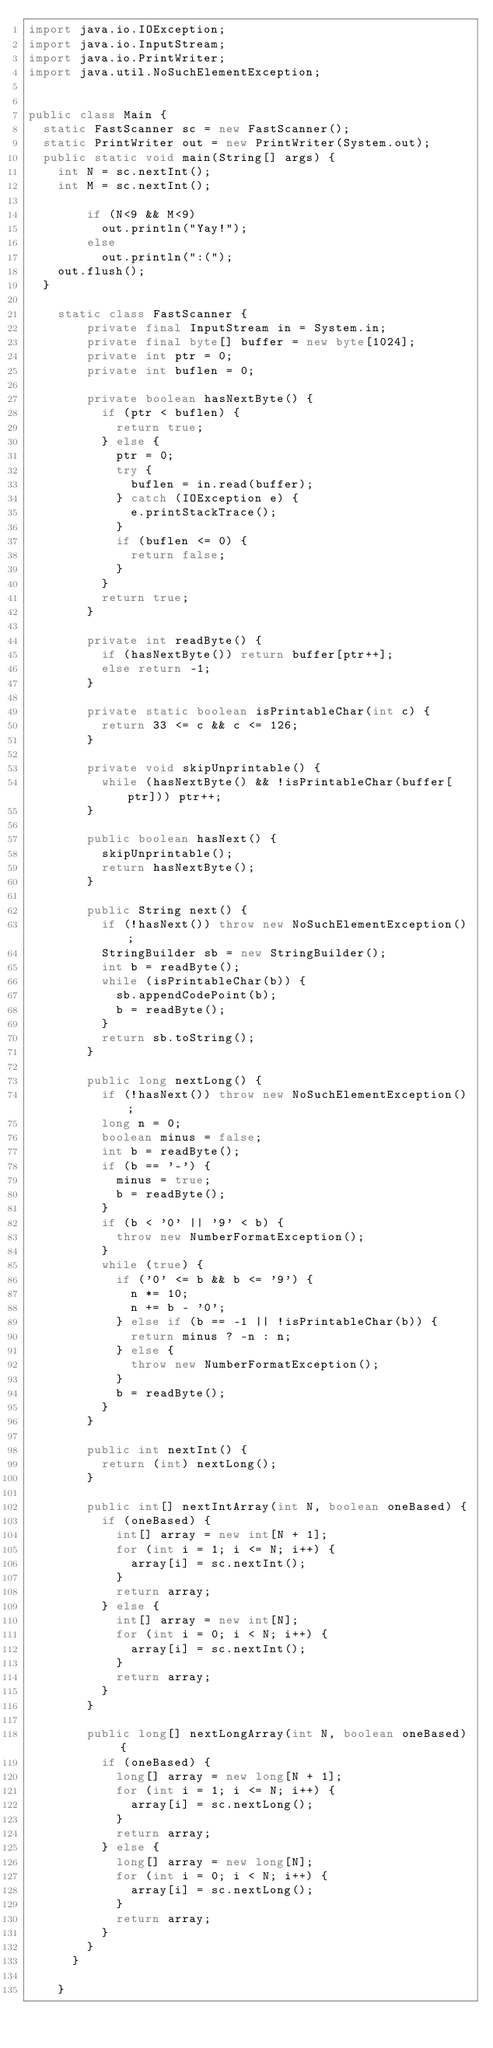<code> <loc_0><loc_0><loc_500><loc_500><_Java_>import java.io.IOException;
import java.io.InputStream;
import java.io.PrintWriter;
import java.util.NoSuchElementException;


public class Main {
	static FastScanner sc = new FastScanner();
	static PrintWriter out = new PrintWriter(System.out);
	public static void main(String[] args) {
		int N = sc.nextInt();
		int M = sc.nextInt();
	
        if (N<9 && M<9)
        	out.println("Yay!");
        else
        	out.println(":(");
		out.flush();
	}
	
		static class FastScanner {
		    private final InputStream in = System.in;
		    private final byte[] buffer = new byte[1024];
		    private int ptr = 0;
		    private int buflen = 0;

		    private boolean hasNextByte() {
		      if (ptr < buflen) {
		        return true;
		      } else {
		        ptr = 0;
		        try {
		          buflen = in.read(buffer);
		        } catch (IOException e) {
		          e.printStackTrace();
		        }
		        if (buflen <= 0) {
		          return false;
		        }
		      }
		      return true;
		    }

		    private int readByte() {
		      if (hasNextByte()) return buffer[ptr++];
		      else return -1;
		    }

		    private static boolean isPrintableChar(int c) {
		      return 33 <= c && c <= 126;
		    }

		    private void skipUnprintable() {
		      while (hasNextByte() && !isPrintableChar(buffer[ptr])) ptr++;
		    }

		    public boolean hasNext() {
		      skipUnprintable();
		      return hasNextByte();
		    }

		    public String next() {
		      if (!hasNext()) throw new NoSuchElementException();
		      StringBuilder sb = new StringBuilder();
		      int b = readByte();
		      while (isPrintableChar(b)) {
		        sb.appendCodePoint(b);
		        b = readByte();
		      }
		      return sb.toString();
		    }

		    public long nextLong() {
		      if (!hasNext()) throw new NoSuchElementException();
		      long n = 0;
		      boolean minus = false;
		      int b = readByte();
		      if (b == '-') {
		        minus = true;
		        b = readByte();
		      }
		      if (b < '0' || '9' < b) {
		        throw new NumberFormatException();
		      }
		      while (true) {
		        if ('0' <= b && b <= '9') {
		          n *= 10;
		          n += b - '0';
		        } else if (b == -1 || !isPrintableChar(b)) {
		          return minus ? -n : n;
		        } else {
		          throw new NumberFormatException();
		        }
		        b = readByte();
		      }
		    }

		    public int nextInt() {
		      return (int) nextLong();
		    }

		    public int[] nextIntArray(int N, boolean oneBased) {
		      if (oneBased) {
		        int[] array = new int[N + 1];
		        for (int i = 1; i <= N; i++) {
		          array[i] = sc.nextInt();
		        }
		        return array;
		      } else {
		        int[] array = new int[N];
		        for (int i = 0; i < N; i++) {
		          array[i] = sc.nextInt();
		        }
		        return array;
		      }
		    }

		    public long[] nextLongArray(int N, boolean oneBased) {
		      if (oneBased) {
		        long[] array = new long[N + 1];
		        for (int i = 1; i <= N; i++) {
		          array[i] = sc.nextLong();
		        }
		        return array;
		      } else {
		        long[] array = new long[N];
		        for (int i = 0; i < N; i++) {
		          array[i] = sc.nextLong();
		        }
		        return array;
		      }
		    }
		  }

		}	 



</code> 